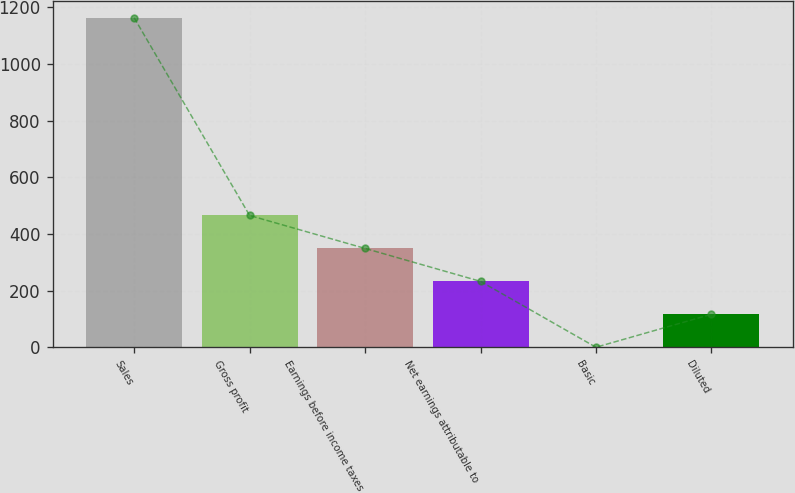<chart> <loc_0><loc_0><loc_500><loc_500><bar_chart><fcel>Sales<fcel>Gross profit<fcel>Earnings before income taxes<fcel>Net earnings attributable to<fcel>Basic<fcel>Diluted<nl><fcel>1162.2<fcel>465.2<fcel>349.04<fcel>232.88<fcel>0.56<fcel>116.72<nl></chart> 